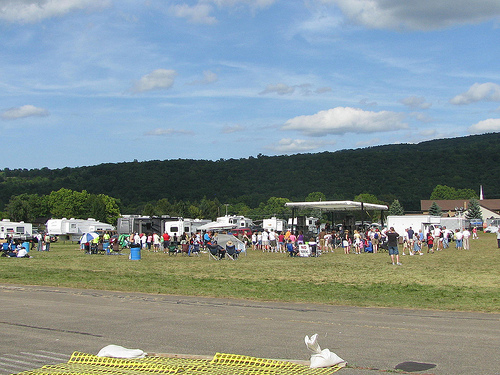<image>
Is there a people on the field? Yes. Looking at the image, I can see the people is positioned on top of the field, with the field providing support. Is there a sky behind the tree? Yes. From this viewpoint, the sky is positioned behind the tree, with the tree partially or fully occluding the sky. 